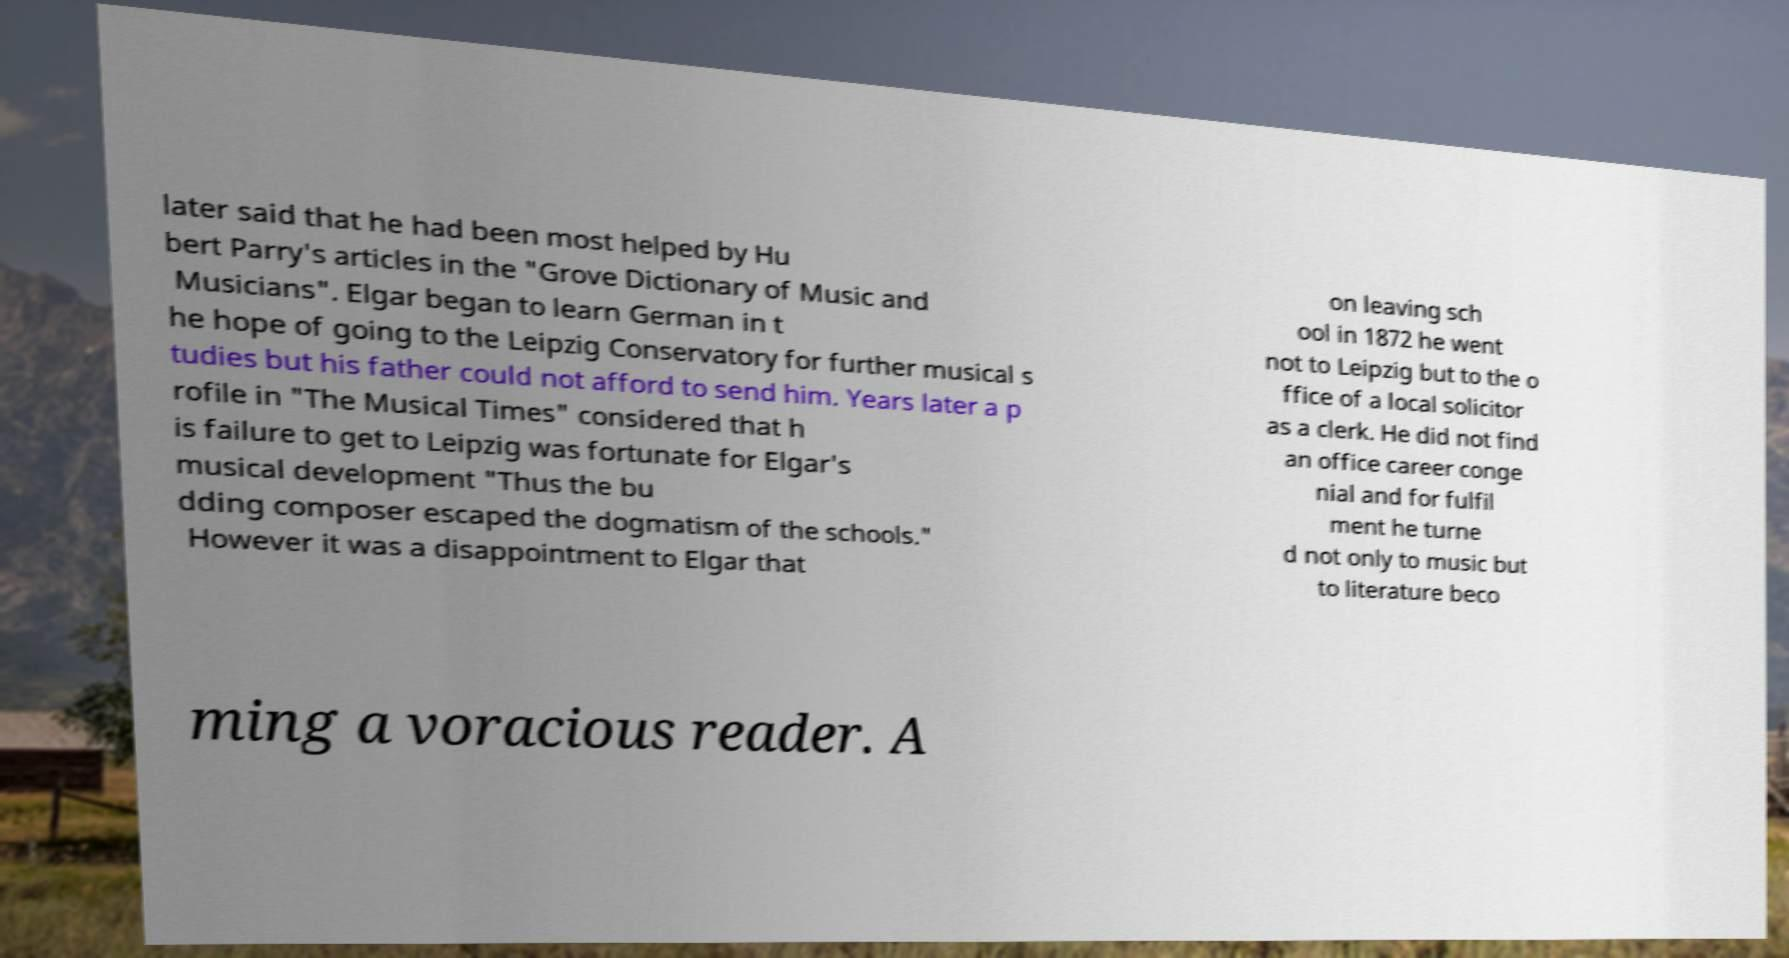Can you accurately transcribe the text from the provided image for me? later said that he had been most helped by Hu bert Parry's articles in the "Grove Dictionary of Music and Musicians". Elgar began to learn German in t he hope of going to the Leipzig Conservatory for further musical s tudies but his father could not afford to send him. Years later a p rofile in "The Musical Times" considered that h is failure to get to Leipzig was fortunate for Elgar's musical development "Thus the bu dding composer escaped the dogmatism of the schools." However it was a disappointment to Elgar that on leaving sch ool in 1872 he went not to Leipzig but to the o ffice of a local solicitor as a clerk. He did not find an office career conge nial and for fulfil ment he turne d not only to music but to literature beco ming a voracious reader. A 